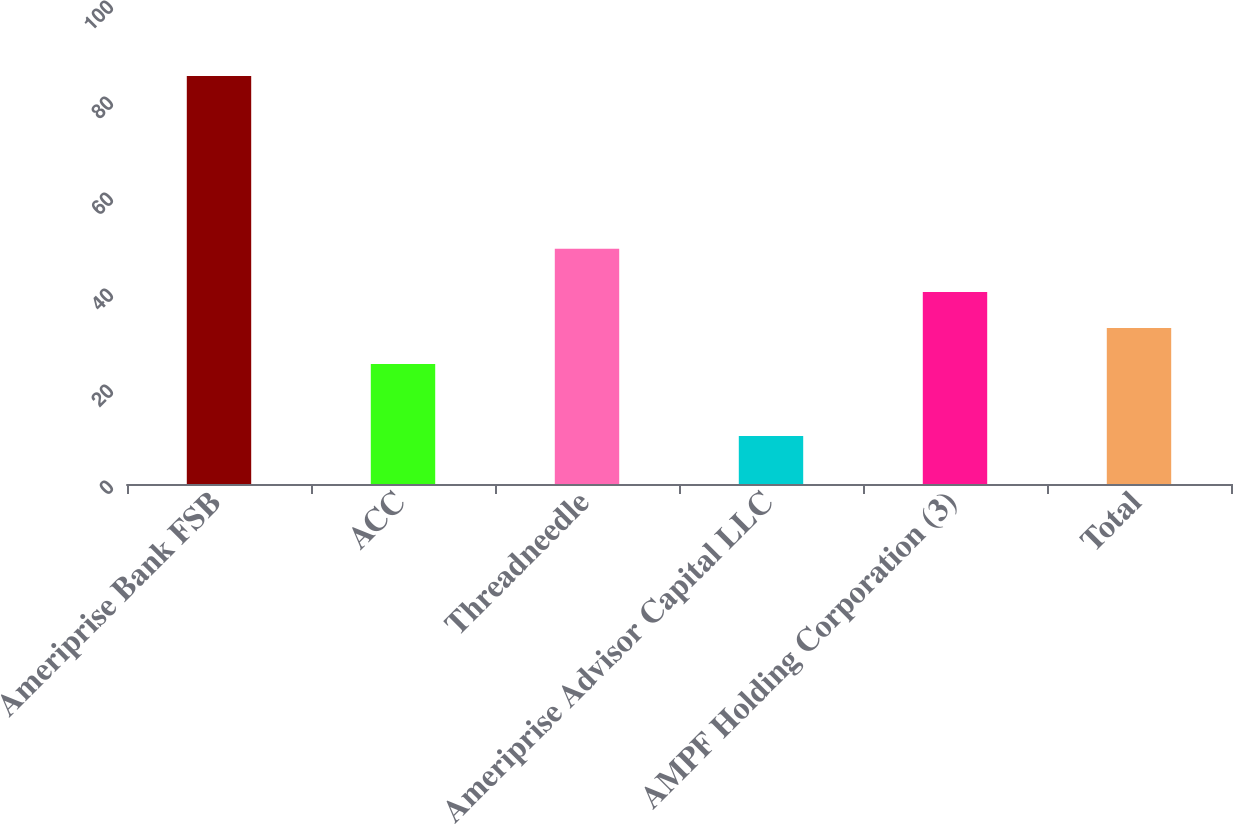<chart> <loc_0><loc_0><loc_500><loc_500><bar_chart><fcel>Ameriprise Bank FSB<fcel>ACC<fcel>Threadneedle<fcel>Ameriprise Advisor Capital LLC<fcel>AMPF Holding Corporation (3)<fcel>Total<nl><fcel>85<fcel>25<fcel>49<fcel>10<fcel>40<fcel>32.5<nl></chart> 